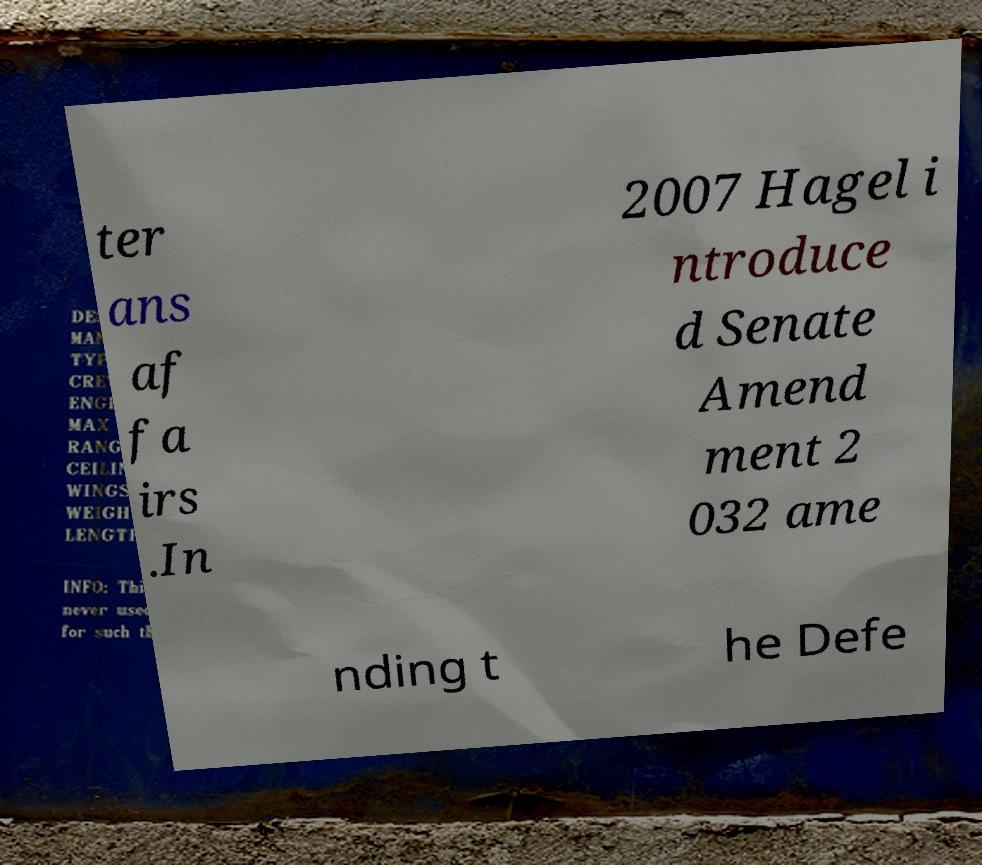What messages or text are displayed in this image? I need them in a readable, typed format. ter ans af fa irs .In 2007 Hagel i ntroduce d Senate Amend ment 2 032 ame nding t he Defe 